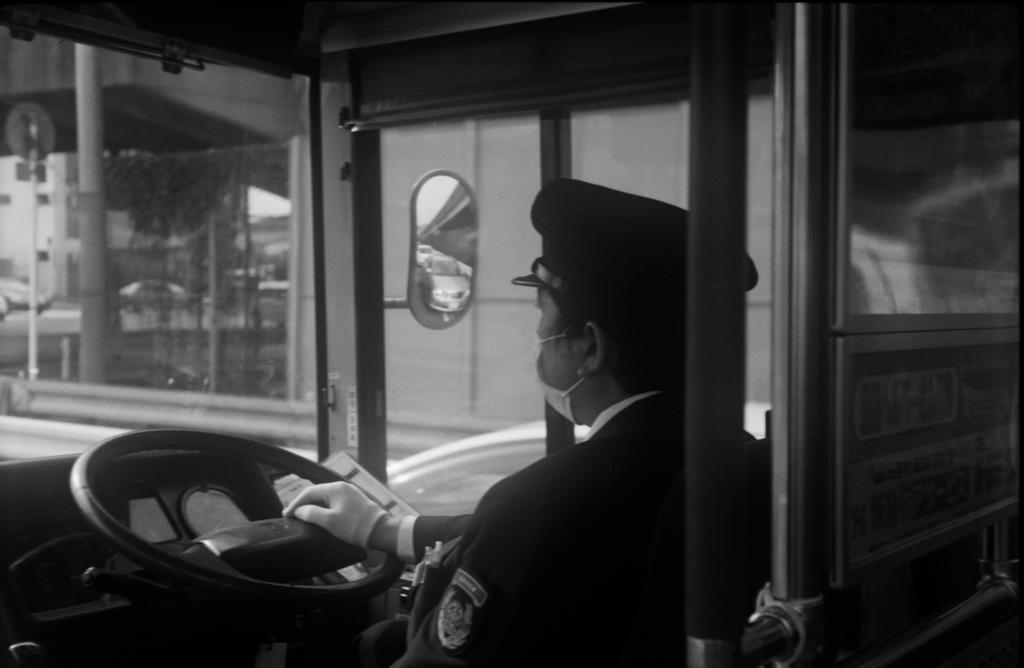What is the color scheme of the image? The image is black and white. What can be seen inside the vehicle in the image? There is a person sitting inside the vehicle. What is the person likely to be using while sitting in the vehicle? The steering wheel is visible in the image, which the person might be using. What object is used for reflection in the image? There is a mirror in the image. What type of structures are present in the image? There are poles present in the image. What type of bat is hanging from the mirror in the image? There is no bat present in the image; it is a black and white image featuring a person sitting inside a vehicle. How much salt is visible on the poles in the image? There is no salt visible on the poles in the image; the poles are likely used for support or signage purposes. 